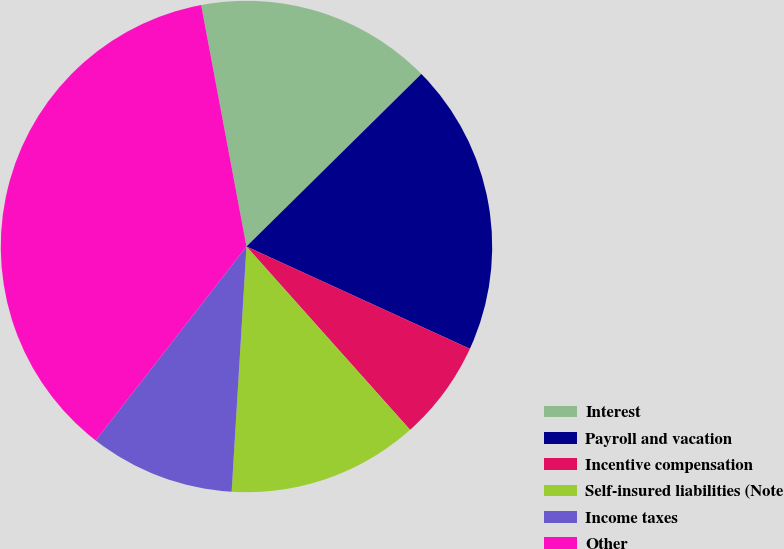Convert chart to OTSL. <chart><loc_0><loc_0><loc_500><loc_500><pie_chart><fcel>Interest<fcel>Payroll and vacation<fcel>Incentive compensation<fcel>Self-insured liabilities (Note<fcel>Income taxes<fcel>Other<nl><fcel>15.56%<fcel>19.23%<fcel>6.57%<fcel>12.56%<fcel>9.56%<fcel>36.53%<nl></chart> 